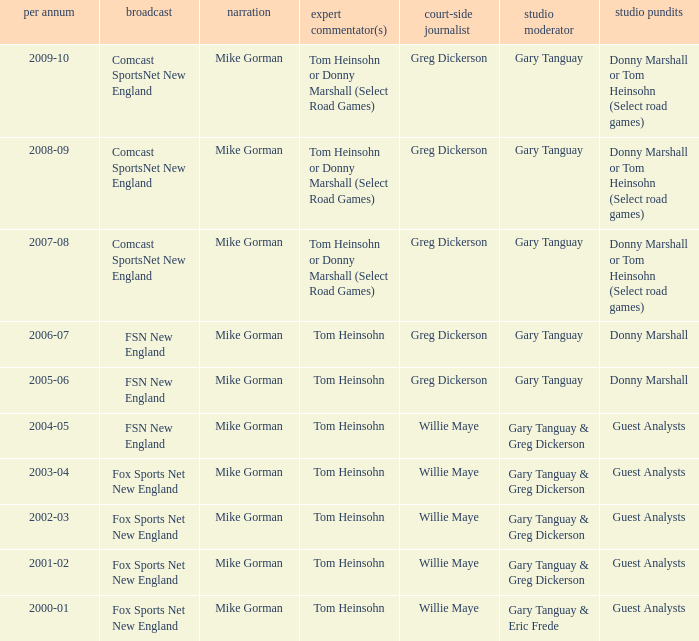Which Courtside reporter has a Channel of fsn new england in 2006-07? Greg Dickerson. 